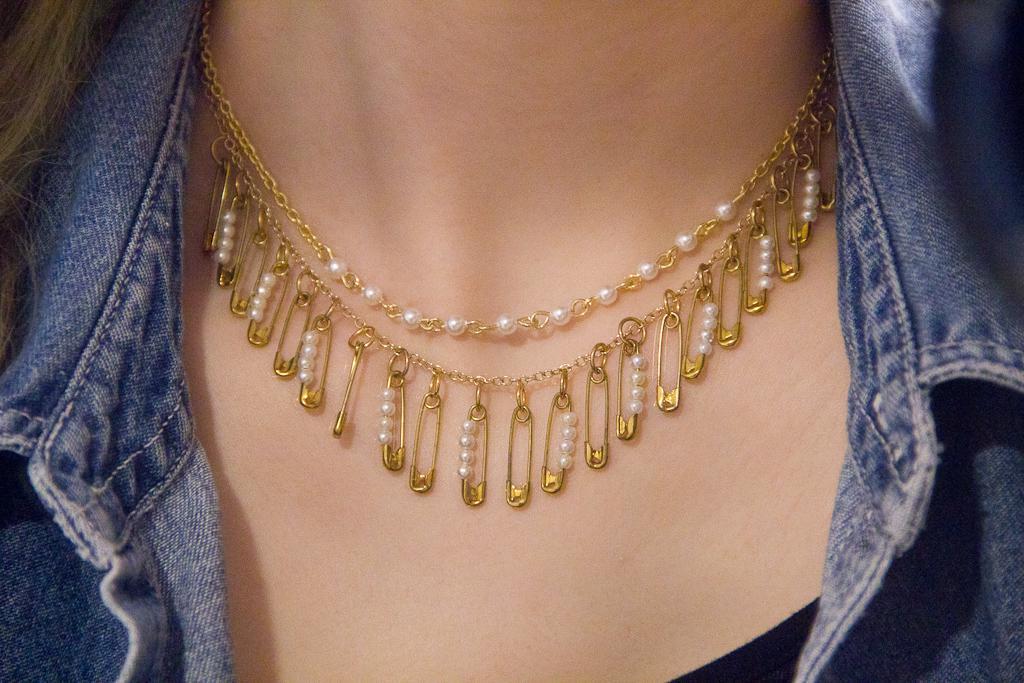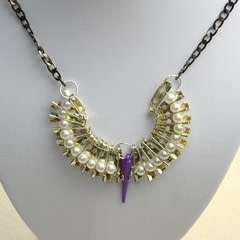The first image is the image on the left, the second image is the image on the right. For the images displayed, is the sentence "One of the necklaces is not dangling around a neck." factually correct? Answer yes or no. Yes. The first image is the image on the left, the second image is the image on the right. Examine the images to the left and right. Is the description "Both images show a model wearing a necklace." accurate? Answer yes or no. No. 